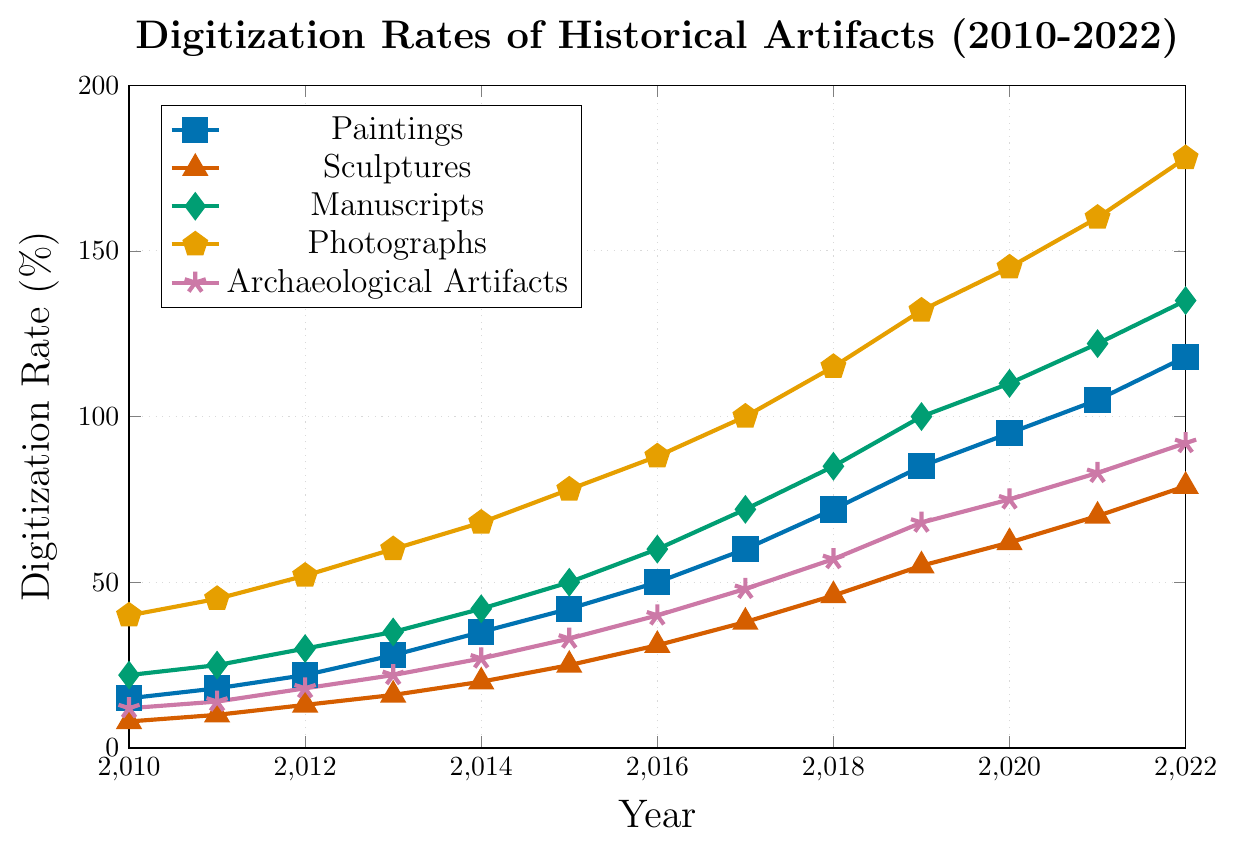What year did Paintings surpass a digitization rate of 50%? According to the figure, in the year 2016, the digitization rate of Paintings surpasses 50%.
Answer: 2016 How many artifact types had a digitization rate greater than 100% in 2022? Observing the figure's data for 2022, Manuscripts, Photographs, and Paintings all have digitization rates greater than 100%. Count these artifact types.
Answer: 3 Which artifact type had the lowest digitization rate in 2015, and what was the rate? According to the figure, Sculptures had the lowest digitization rate in 2015, which was 25%.
Answer: Sculptures, 25% In what year did Photographs reach a digitization rate of 100%? Looking at the figure, the digitization rate of Photographs reached 100% in the year 2017.
Answer: 2017 By how much did the digitization rate of Archaeological Artifacts increase from 2010 to 2022? From the figure, the digitization rate for Archaeological Artifacts in 2010 was 12% and in 2022 was 92%. Subtract the 2010 rate from the 2022 rate (92 - 12).
Answer: 80% Which artifact type had the highest digitization rate overall in the plotted years, and what was the rate? Observing the figure, the highest overall digitization rate is for Photographs in 2022, which was 178%.
Answer: Photographs, 178% Compare the digitization rates of Paintings and Manuscripts in 2017. Which was higher and by how much? In 2017, Paintings had a digitization rate of 60%, and Manuscripts had a digitization rate of 72%. Subtract the Paintings rate from the Manuscripts rate (72 - 60).
Answer: Manuscripts, 12% What is the average digitization rate of Sculptures from 2010 to 2022? Sum the digitization rates of Sculptures from 2010 to 2022 (8 + 10 + 13 + 16 + 20 + 25 + 31 + 38 + 46 + 55 + 62 + 70 + 79 = 473) and divide by 13 years (473 / 13).
Answer: 36.38% What was the trend in the digitization rate of Paintings from 2010 to 2022? The figure shows a consistent increase in the digitization rate of Paintings each year from 2010 to 2022.
Answer: Increasing Which artifact type had the closest digitization rate to 50% in 2018? According to the figure, Sculptures had a digitization rate of 46% in 2018, which is closest to 50%.
Answer: Sculptures 